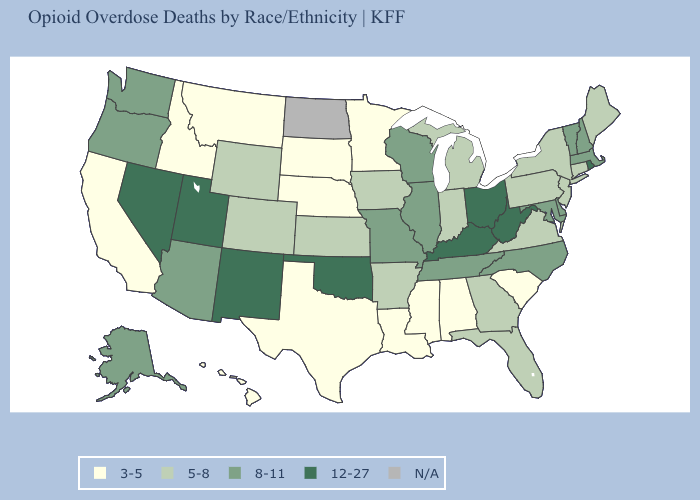What is the value of Iowa?
Answer briefly. 5-8. What is the highest value in states that border Colorado?
Give a very brief answer. 12-27. Does Ohio have the highest value in the USA?
Give a very brief answer. Yes. Name the states that have a value in the range 5-8?
Write a very short answer. Arkansas, Colorado, Connecticut, Florida, Georgia, Indiana, Iowa, Kansas, Maine, Michigan, New Jersey, New York, Pennsylvania, Virginia, Wyoming. Does the map have missing data?
Be succinct. Yes. Among the states that border Wisconsin , which have the lowest value?
Give a very brief answer. Minnesota. What is the value of Missouri?
Short answer required. 8-11. Does the first symbol in the legend represent the smallest category?
Short answer required. Yes. Does the map have missing data?
Short answer required. Yes. What is the value of Iowa?
Be succinct. 5-8. Is the legend a continuous bar?
Give a very brief answer. No. Does Nebraska have the lowest value in the MidWest?
Write a very short answer. Yes. What is the lowest value in the South?
Write a very short answer. 3-5. How many symbols are there in the legend?
Answer briefly. 5. 